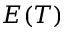<formula> <loc_0><loc_0><loc_500><loc_500>E ( T )</formula> 